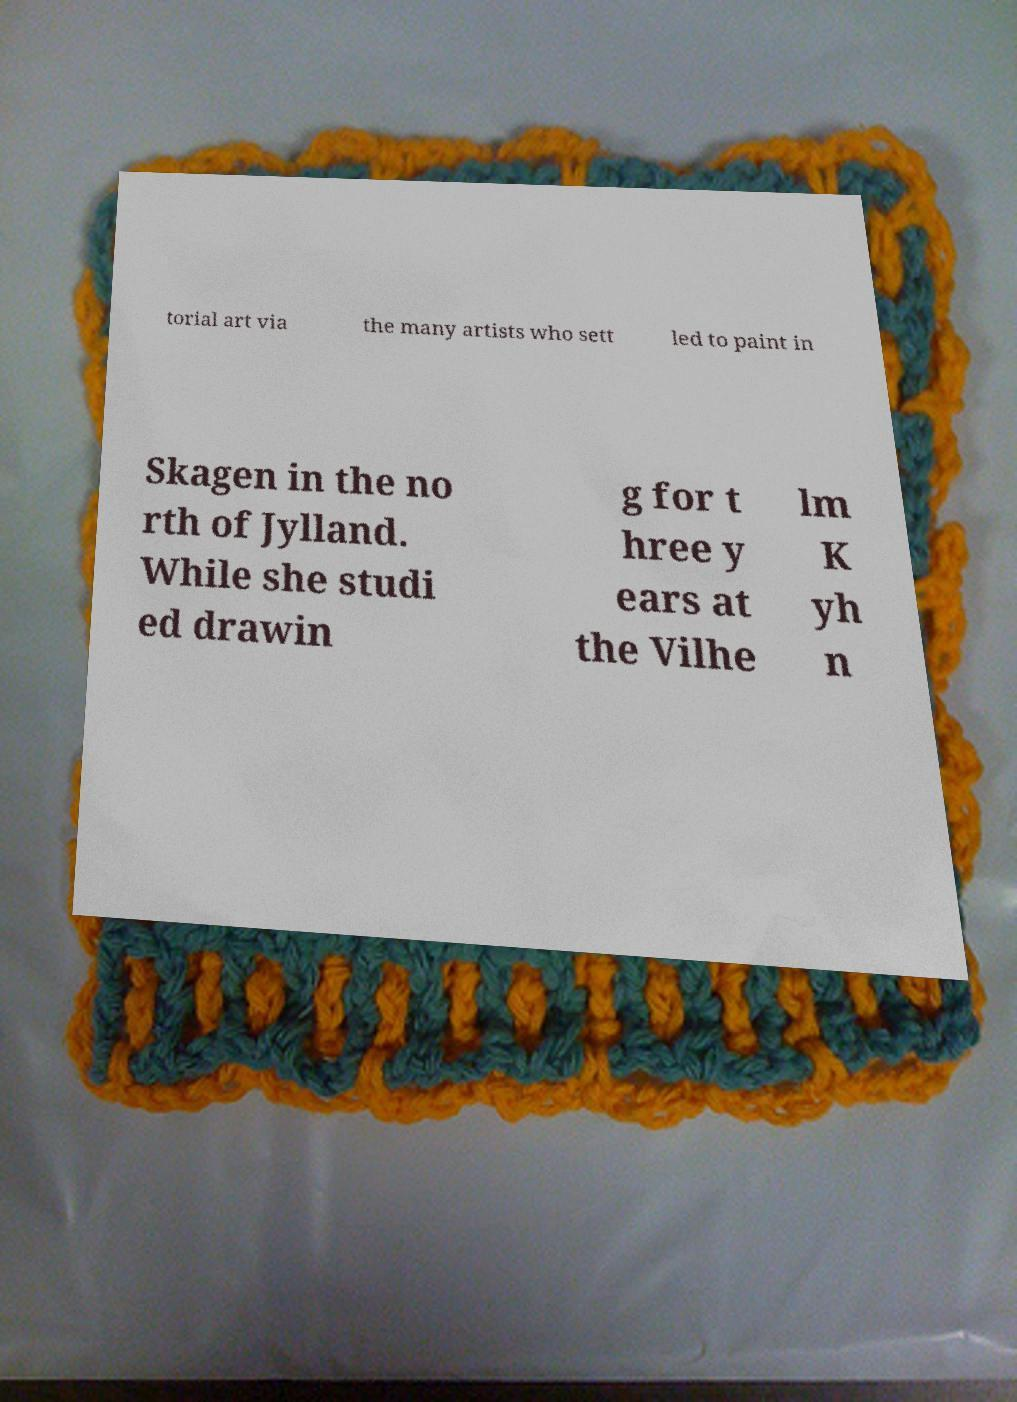There's text embedded in this image that I need extracted. Can you transcribe it verbatim? torial art via the many artists who sett led to paint in Skagen in the no rth of Jylland. While she studi ed drawin g for t hree y ears at the Vilhe lm K yh n 